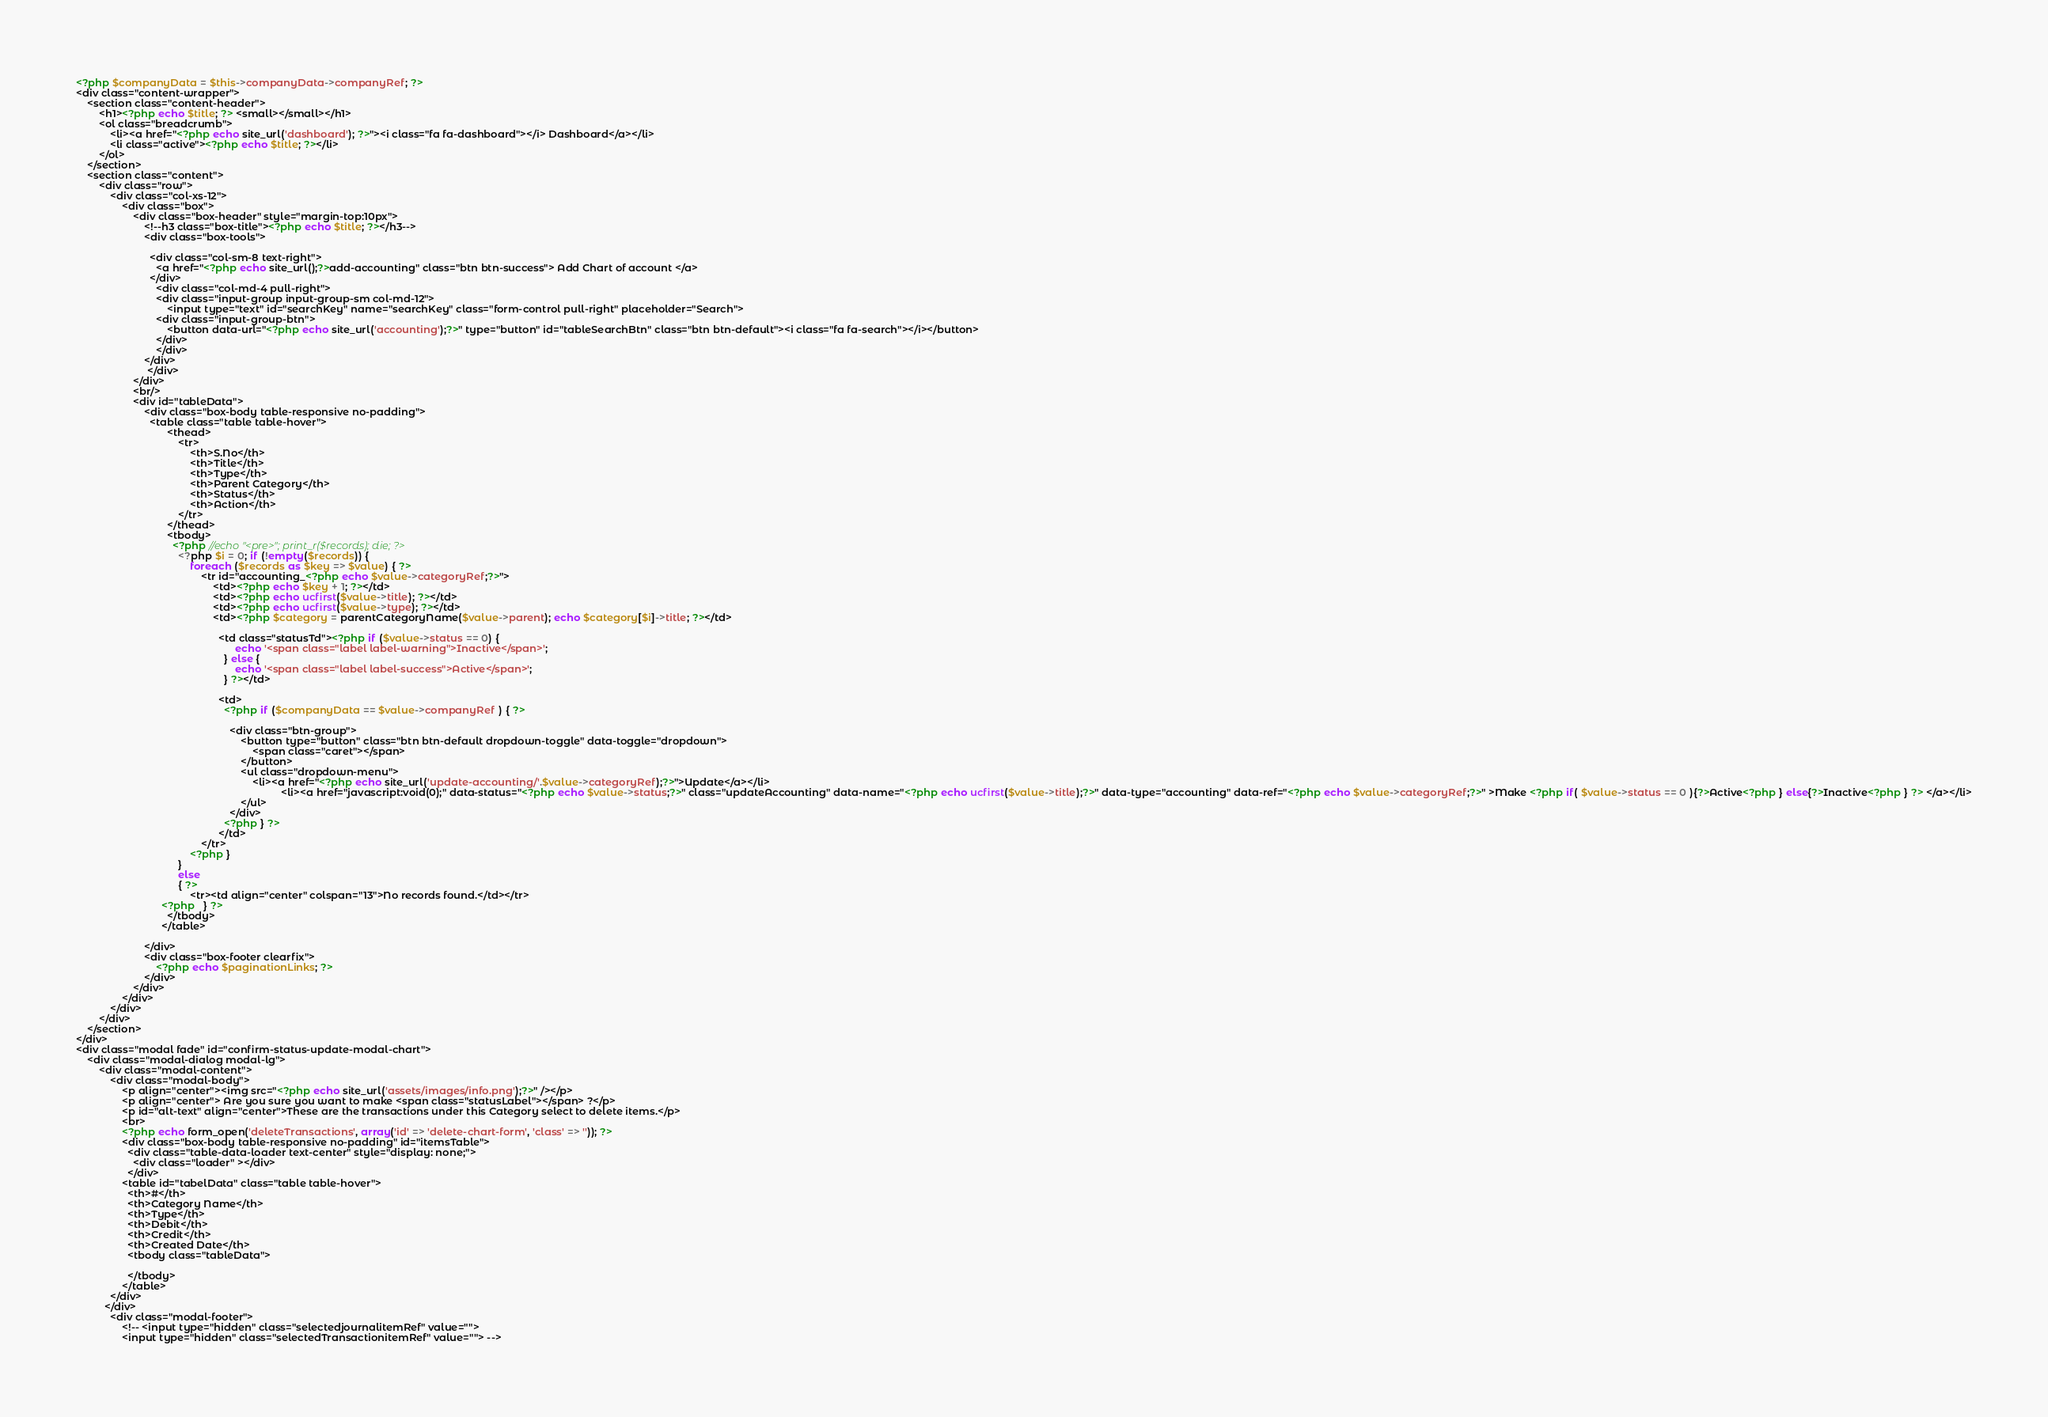Convert code to text. <code><loc_0><loc_0><loc_500><loc_500><_PHP_><?php $companyData = $this->companyData->companyRef; ?>
<div class="content-wrapper">
    <section class="content-header">
        <h1><?php echo $title; ?> <small></small></h1>
        <ol class="breadcrumb">
            <li><a href="<?php echo site_url('dashboard'); ?>"><i class="fa fa-dashboard"></i> Dashboard</a></li>
            <li class="active"><?php echo $title; ?></li>
        </ol>
    </section>
    <section class="content">
        <div class="row">
            <div class="col-xs-12">
                <div class="box">
                    <div class="box-header" style="margin-top:10px">
                        <!--h3 class="box-title"><?php echo $title; ?></h3-->
                        <div class="box-tools">

                          <div class="col-sm-8 text-right">
                            <a href="<?php echo site_url();?>add-accounting" class="btn btn-success"> Add Chart of account </a>
                          </div>
                            <div class="col-md-4 pull-right">
                            <div class="input-group input-group-sm col-md-12">
                                <input type="text" id="searchKey" name="searchKey" class="form-control pull-right" placeholder="Search">
                            <div class="input-group-btn">
                                <button data-url="<?php echo site_url('accounting');?>" type="button" id="tableSearchBtn" class="btn btn-default"><i class="fa fa-search"></i></button>
                            </div>
                            </div>
                        </div>
                         </div>
                    </div>
                    <br/>
                    <div id="tableData">
                        <div class="box-body table-responsive no-padding">
                          <table class="table table-hover">
                                <thead>
                                    <tr>
                                        <th>S.No</th>
                                        <th>Title</th>
                                        <th>Type</th>
                                        <th>Parent Category</th>
                                        <th>Status</th>
                                        <th>Action</th>
                                    </tr>
                                </thead>
                                <tbody>
                                  <?php //echo "<pre>"; print_r($records); die; ?>
                                    <?php $i = 0; if (!empty($records)) {
                                        foreach ($records as $key => $value) { ?>
                                            <tr id="accounting_<?php echo $value->categoryRef;?>">
                                                <td><?php echo $key + 1; ?></td>
                                                <td><?php echo ucfirst($value->title); ?></td>
                                                <td><?php echo ucfirst($value->type); ?></td>
                                                <td><?php $category = parentCategoryName($value->parent); echo $category[$i]->title; ?></td>

                                                  <td class="statusTd"><?php if ($value->status == 0) {
                                                        echo '<span class="label label-warning">Inactive</span>';
                                                    } else {
                                                        echo '<span class="label label-success">Active</span>';
                                                    } ?></td>

                                                  <td>
                                                    <?php if ($companyData == $value->companyRef ) { ?>

                                                      <div class="btn-group">
                                                          <button type="button" class="btn btn-default dropdown-toggle" data-toggle="dropdown">
                                                              <span class="caret"></span>
                                                          </button>
                                                          <ul class="dropdown-menu">
                                                              <li><a href="<?php echo site_url('update-accounting/'.$value->categoryRef);?>">Update</a></li>
          						                                        <li><a href="javascript:void(0);" data-status="<?php echo $value->status;?>" class="updateAccounting" data-name="<?php echo ucfirst($value->title);?>" data-type="accounting" data-ref="<?php echo $value->categoryRef;?>" >Make <?php if( $value->status == 0 ){?>Active<?php } else{?>Inactive<?php } ?> </a></li>
                                                          </ul>
                                                      </div>
                                                    <?php } ?>
                                                  </td>
                                            </tr>
                                        <?php }
                                    }
                                    else
                                    { ?>
                                        <tr><td align="center" colspan="13">No records found.</td></tr>
                              <?php   } ?>
                                </tbody>
                              </table>

                        </div>
                        <div class="box-footer clearfix">
                            <?php echo $paginationLinks; ?>
                        </div>
                    </div>
                </div>
            </div>
        </div>
    </section>
</div>
<div class="modal fade" id="confirm-status-update-modal-chart">
    <div class="modal-dialog modal-lg">
        <div class="modal-content">
            <div class="modal-body">
                <p align="center"><img src="<?php echo site_url('assets/images/info.png');?>" /></p>
                <p align="center"> Are you sure you want to make <span class="statusLabel"></span> ?</p>
                <p id="alt-text" align="center">These are the transactions under this Category select to delete items.</p>
                <br>
                <?php echo form_open('deleteTransactions', array('id' => 'delete-chart-form', 'class' => '')); ?>
                <div class="box-body table-responsive no-padding" id="itemsTable">
                  <div class="table-data-loader text-center" style="display: none;">
                  	<div class="loader" ></div>
                  </div>
                <table id="tabelData" class="table table-hover">
                  <th>#</th>
                  <th>Category Name</th>
                  <th>Type</th>
                  <th>Debit</th>
                  <th>Credit</th>
                  <th>Created Date</th>
                  <tbody class="tableData">

                  </tbody>
                </table>
            </div>
          </div>
            <div class="modal-footer">
                <!-- <input type="hidden" class="selectedjournalitemRef" value="">
                <input type="hidden" class="selectedTransactionitemRef" value=""> --></code> 